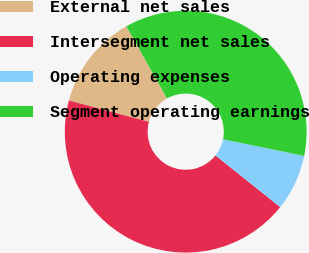Convert chart. <chart><loc_0><loc_0><loc_500><loc_500><pie_chart><fcel>External net sales<fcel>Intersegment net sales<fcel>Operating expenses<fcel>Segment operating earnings<nl><fcel>12.68%<fcel>43.43%<fcel>7.51%<fcel>36.38%<nl></chart> 